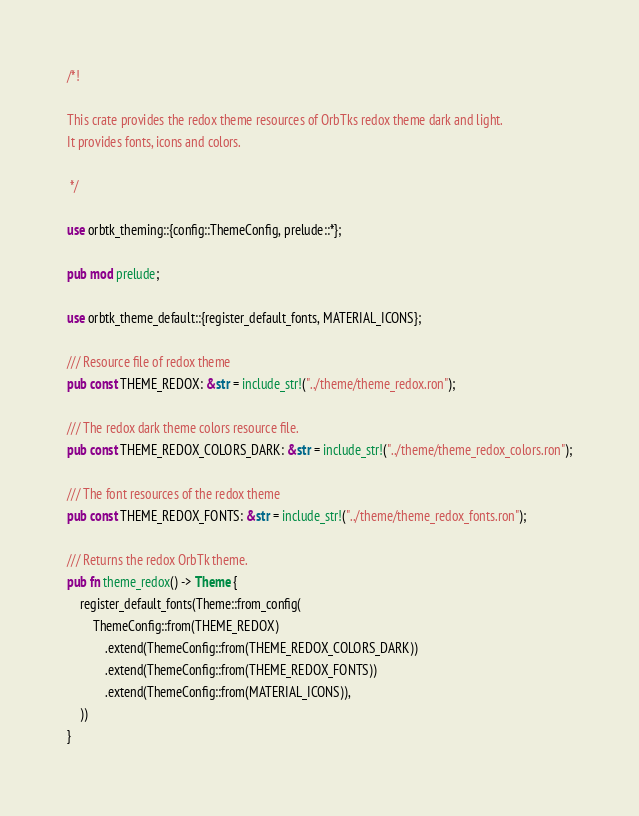<code> <loc_0><loc_0><loc_500><loc_500><_Rust_>/*!

This crate provides the redox theme resources of OrbTks redox theme dark and light.
It provides fonts, icons and colors.

 */

use orbtk_theming::{config::ThemeConfig, prelude::*};

pub mod prelude;

use orbtk_theme_default::{register_default_fonts, MATERIAL_ICONS};

/// Resource file of redox theme
pub const THEME_REDOX: &str = include_str!("../theme/theme_redox.ron");

/// The redox dark theme colors resource file.
pub const THEME_REDOX_COLORS_DARK: &str = include_str!("../theme/theme_redox_colors.ron");

/// The font resources of the redox theme
pub const THEME_REDOX_FONTS: &str = include_str!("../theme/theme_redox_fonts.ron");

/// Returns the redox OrbTk theme.
pub fn theme_redox() -> Theme {
    register_default_fonts(Theme::from_config(
        ThemeConfig::from(THEME_REDOX)
            .extend(ThemeConfig::from(THEME_REDOX_COLORS_DARK))
            .extend(ThemeConfig::from(THEME_REDOX_FONTS))
            .extend(ThemeConfig::from(MATERIAL_ICONS)),
    ))
}
</code> 